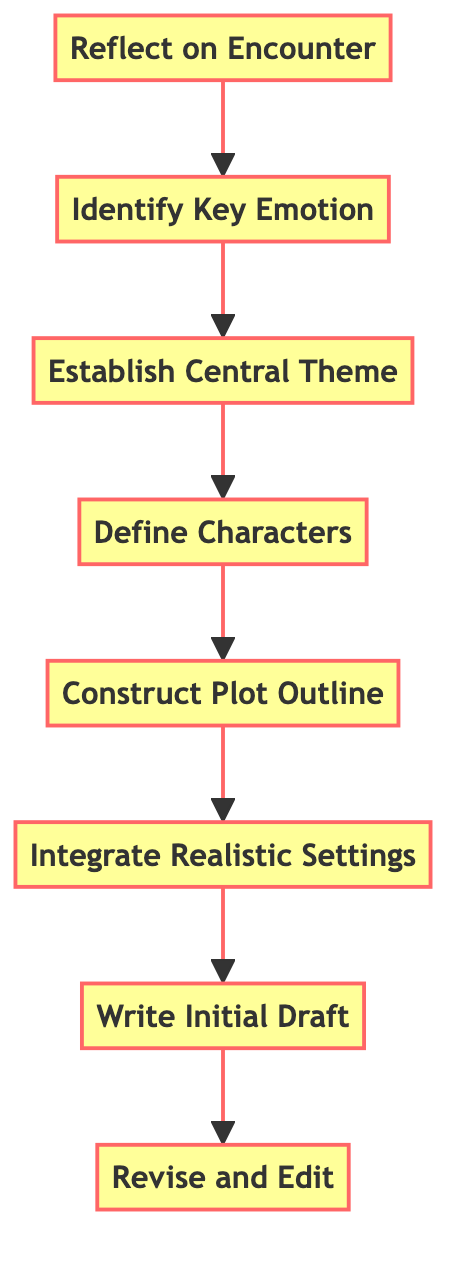What is the first step in the process? The first step in the flow chart is "Reflect on Encounter," which is positioned at the bottom of the diagram.
Answer: Reflect on Encounter How many steps are there in total? By counting each node in the diagram, we find there are a total of eight steps, from "Reflect on Encounter" to "Revise and Edit."
Answer: Eight What step comes after "Identify Key Emotion"? In the flow chart, "Establish Central Theme" directly follows the "Identify Key Emotion" node, indicating the next step in the process.
Answer: Establish Central Theme Which step is concerned with creating fictional characters? The step that involves creating fictional characters based on real-life individuals is named "Define Characters," which can be found after "Establish Central Theme."
Answer: Define Characters What are the last two steps in the flow? The final two steps in the flow chart are "Write Initial Draft" and "Revise and Edit," indicating they are the last actions in this narrative-building process.
Answer: Write Initial Draft, Revise and Edit How does one progress from defining characters to constructing a plot outline? The chart demonstrates a direct flow from "Define Characters" to "Construct Plot Outline," indicating that once characters are established, the next logical step is to outline the plot.
Answer: Define Characters to Construct Plot Outline Which step deals with settings? The step that focuses on settings is "Integrate Realistic Settings," which comes after "Construct Plot Outline" in the narrative development sequence.
Answer: Integrate Realistic Settings What is required before writing the initial draft? Before progressing to "Write Initial Draft," one must first "Integrate Realistic Settings," ensuring that the environment is properly detailed before drafting the story.
Answer: Integrate Realistic Settings What is the relationship between the steps "Revise and Edit" and "Write Initial Draft"? "Revise and Edit" directly follows "Write Initial Draft," suggesting that after composing the initial draft, the subsequent necessary step is refinement and editing.
Answer: Write Initial Draft to Revise and Edit 